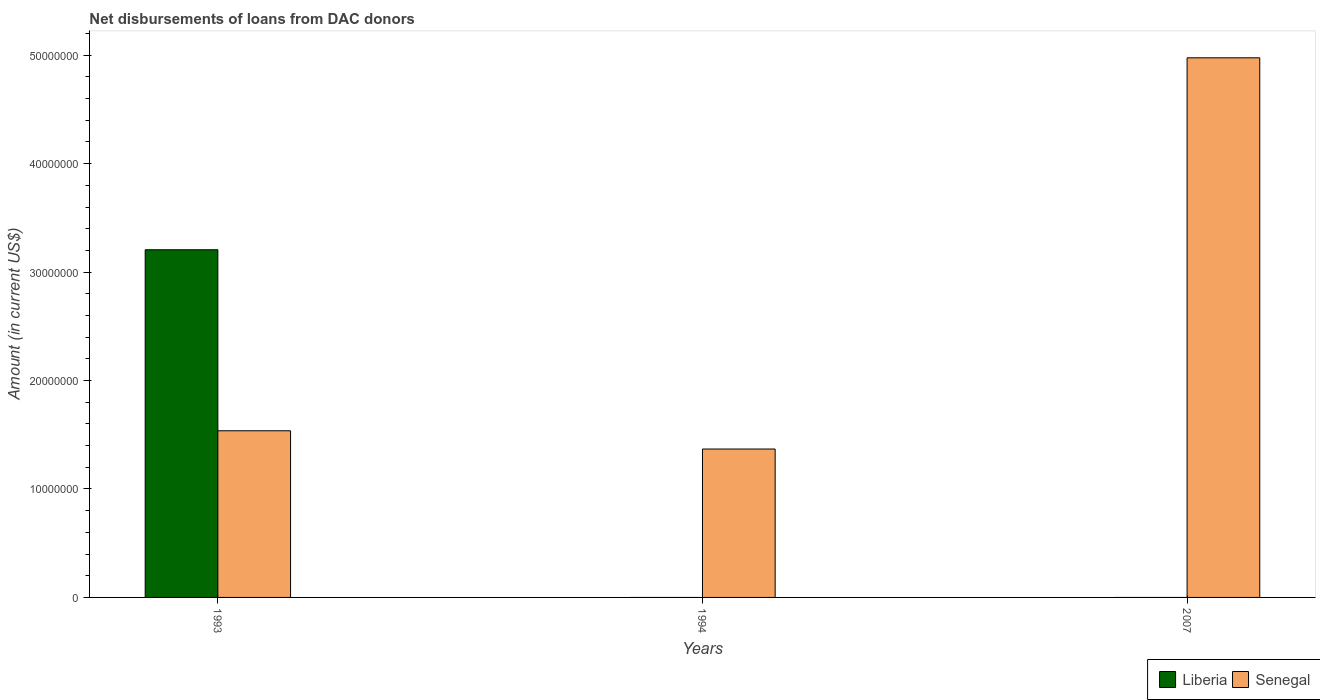Are the number of bars on each tick of the X-axis equal?
Give a very brief answer. No. How many bars are there on the 3rd tick from the left?
Keep it short and to the point. 1. What is the amount of loans disbursed in Liberia in 1993?
Your response must be concise. 3.21e+07. Across all years, what is the maximum amount of loans disbursed in Senegal?
Provide a succinct answer. 4.98e+07. What is the total amount of loans disbursed in Senegal in the graph?
Offer a terse response. 7.88e+07. What is the difference between the amount of loans disbursed in Senegal in 1993 and that in 1994?
Offer a very short reply. 1.68e+06. What is the difference between the amount of loans disbursed in Liberia in 1993 and the amount of loans disbursed in Senegal in 1994?
Make the answer very short. 1.84e+07. What is the average amount of loans disbursed in Liberia per year?
Your answer should be very brief. 1.07e+07. In the year 1993, what is the difference between the amount of loans disbursed in Senegal and amount of loans disbursed in Liberia?
Your response must be concise. -1.67e+07. What is the ratio of the amount of loans disbursed in Senegal in 1993 to that in 1994?
Give a very brief answer. 1.12. What is the difference between the highest and the second highest amount of loans disbursed in Senegal?
Ensure brevity in your answer.  3.44e+07. What is the difference between the highest and the lowest amount of loans disbursed in Liberia?
Offer a very short reply. 3.21e+07. In how many years, is the amount of loans disbursed in Liberia greater than the average amount of loans disbursed in Liberia taken over all years?
Make the answer very short. 1. Are all the bars in the graph horizontal?
Give a very brief answer. No. Are the values on the major ticks of Y-axis written in scientific E-notation?
Provide a succinct answer. No. Does the graph contain any zero values?
Keep it short and to the point. Yes. How many legend labels are there?
Your answer should be very brief. 2. How are the legend labels stacked?
Make the answer very short. Horizontal. What is the title of the graph?
Keep it short and to the point. Net disbursements of loans from DAC donors. Does "Middle East & North Africa (all income levels)" appear as one of the legend labels in the graph?
Make the answer very short. No. What is the label or title of the X-axis?
Your answer should be very brief. Years. What is the label or title of the Y-axis?
Keep it short and to the point. Amount (in current US$). What is the Amount (in current US$) of Liberia in 1993?
Give a very brief answer. 3.21e+07. What is the Amount (in current US$) in Senegal in 1993?
Your answer should be very brief. 1.54e+07. What is the Amount (in current US$) of Senegal in 1994?
Ensure brevity in your answer.  1.37e+07. What is the Amount (in current US$) of Senegal in 2007?
Ensure brevity in your answer.  4.98e+07. Across all years, what is the maximum Amount (in current US$) of Liberia?
Ensure brevity in your answer.  3.21e+07. Across all years, what is the maximum Amount (in current US$) in Senegal?
Your answer should be compact. 4.98e+07. Across all years, what is the minimum Amount (in current US$) in Senegal?
Provide a short and direct response. 1.37e+07. What is the total Amount (in current US$) in Liberia in the graph?
Keep it short and to the point. 3.21e+07. What is the total Amount (in current US$) of Senegal in the graph?
Keep it short and to the point. 7.88e+07. What is the difference between the Amount (in current US$) in Senegal in 1993 and that in 1994?
Your response must be concise. 1.68e+06. What is the difference between the Amount (in current US$) in Senegal in 1993 and that in 2007?
Provide a succinct answer. -3.44e+07. What is the difference between the Amount (in current US$) of Senegal in 1994 and that in 2007?
Give a very brief answer. -3.61e+07. What is the difference between the Amount (in current US$) of Liberia in 1993 and the Amount (in current US$) of Senegal in 1994?
Provide a succinct answer. 1.84e+07. What is the difference between the Amount (in current US$) in Liberia in 1993 and the Amount (in current US$) in Senegal in 2007?
Your answer should be very brief. -1.77e+07. What is the average Amount (in current US$) in Liberia per year?
Make the answer very short. 1.07e+07. What is the average Amount (in current US$) of Senegal per year?
Provide a succinct answer. 2.63e+07. In the year 1993, what is the difference between the Amount (in current US$) of Liberia and Amount (in current US$) of Senegal?
Give a very brief answer. 1.67e+07. What is the ratio of the Amount (in current US$) of Senegal in 1993 to that in 1994?
Offer a very short reply. 1.12. What is the ratio of the Amount (in current US$) of Senegal in 1993 to that in 2007?
Offer a terse response. 0.31. What is the ratio of the Amount (in current US$) in Senegal in 1994 to that in 2007?
Your answer should be compact. 0.28. What is the difference between the highest and the second highest Amount (in current US$) in Senegal?
Ensure brevity in your answer.  3.44e+07. What is the difference between the highest and the lowest Amount (in current US$) in Liberia?
Offer a terse response. 3.21e+07. What is the difference between the highest and the lowest Amount (in current US$) in Senegal?
Give a very brief answer. 3.61e+07. 